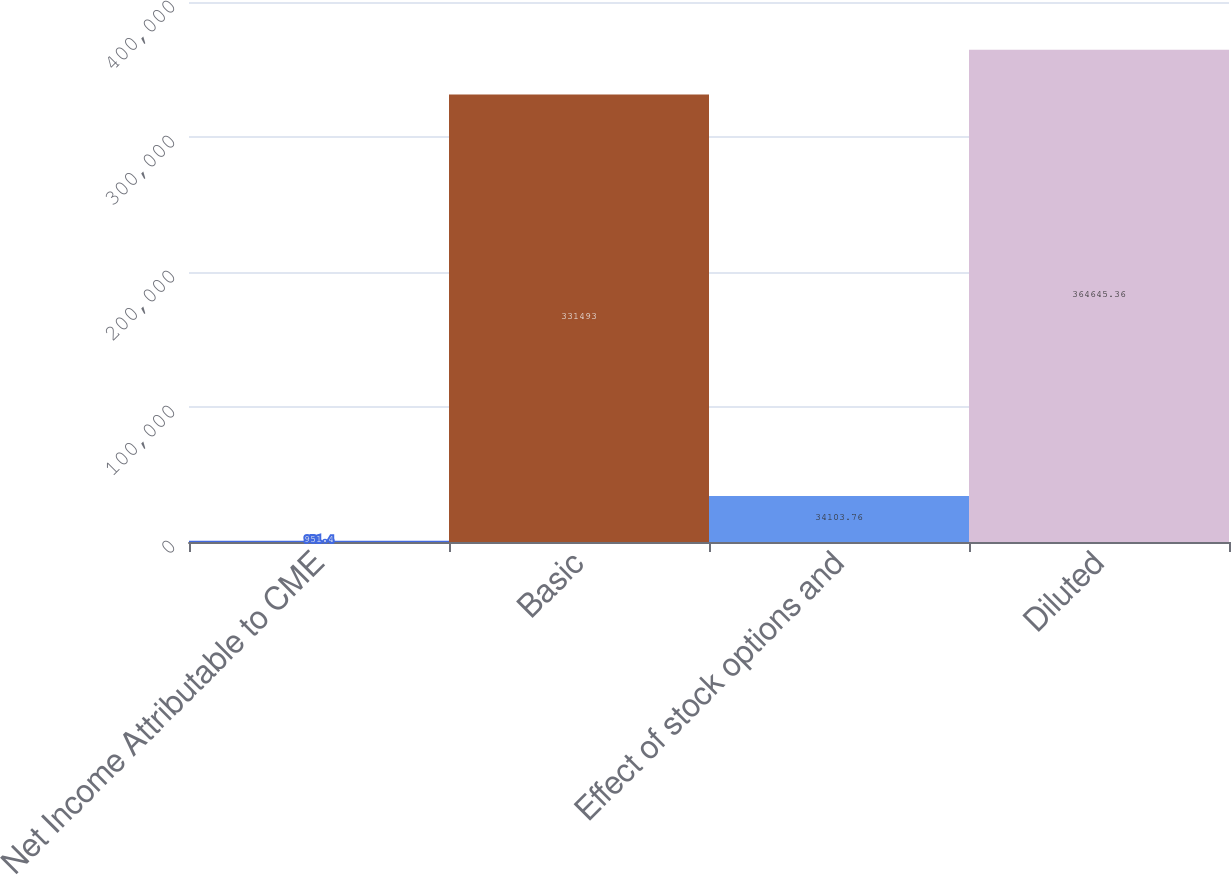<chart> <loc_0><loc_0><loc_500><loc_500><bar_chart><fcel>Net Income Attributable to CME<fcel>Basic<fcel>Effect of stock options and<fcel>Diluted<nl><fcel>951.4<fcel>331493<fcel>34103.8<fcel>364645<nl></chart> 